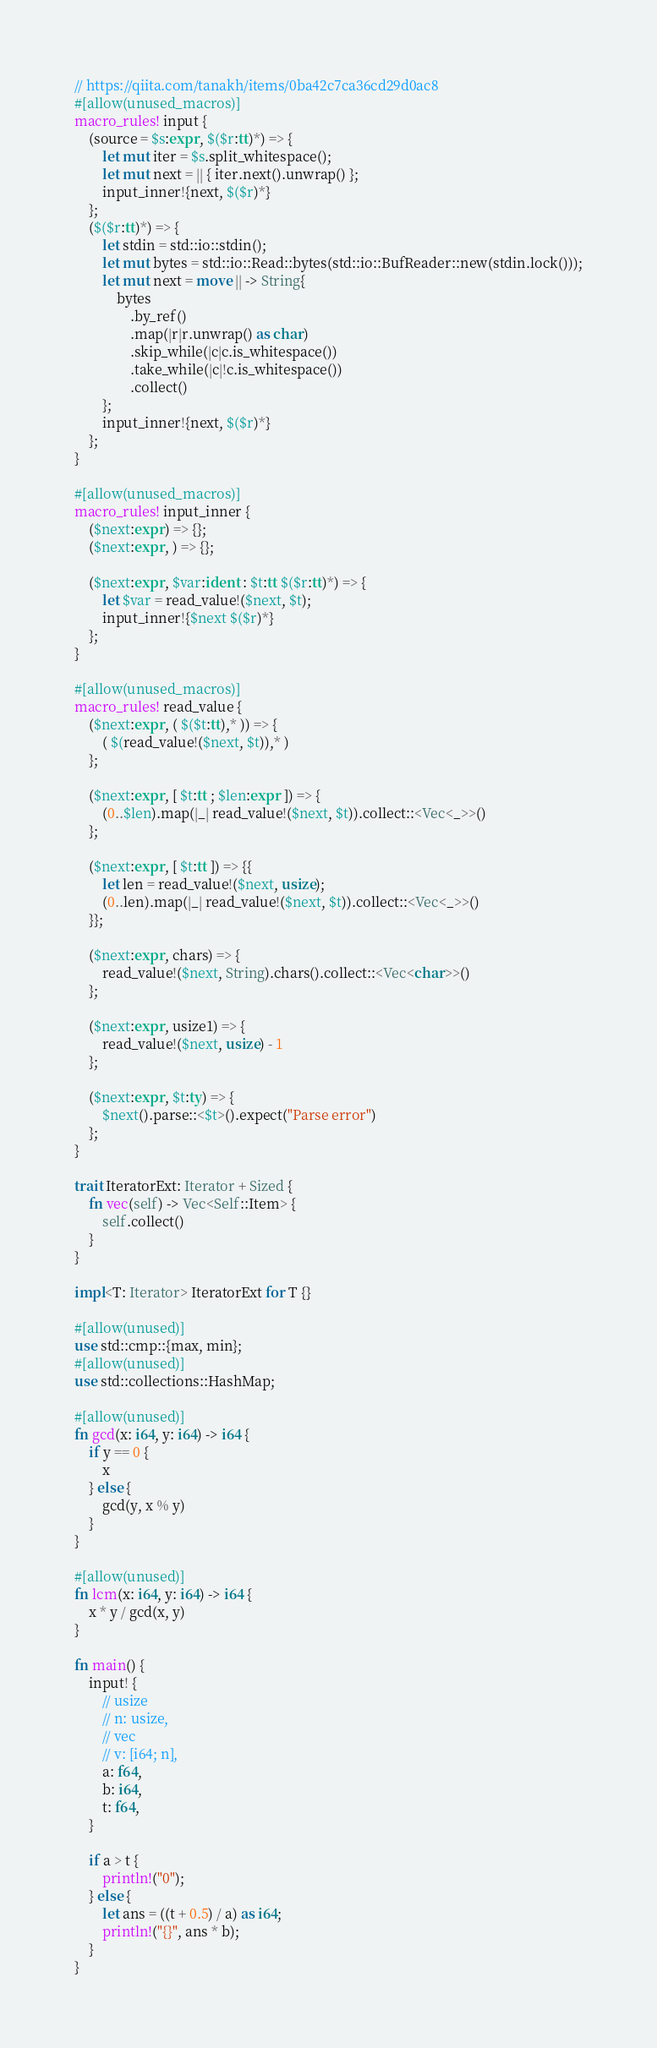Convert code to text. <code><loc_0><loc_0><loc_500><loc_500><_Rust_>// https://qiita.com/tanakh/items/0ba42c7ca36cd29d0ac8
#[allow(unused_macros)]
macro_rules! input {
    (source = $s:expr, $($r:tt)*) => {
        let mut iter = $s.split_whitespace();
        let mut next = || { iter.next().unwrap() };
        input_inner!{next, $($r)*}
    };
    ($($r:tt)*) => {
        let stdin = std::io::stdin();
        let mut bytes = std::io::Read::bytes(std::io::BufReader::new(stdin.lock()));
        let mut next = move || -> String{
            bytes
                .by_ref()
                .map(|r|r.unwrap() as char)
                .skip_while(|c|c.is_whitespace())
                .take_while(|c|!c.is_whitespace())
                .collect()
        };
        input_inner!{next, $($r)*}
    };
}

#[allow(unused_macros)]
macro_rules! input_inner {
    ($next:expr) => {};
    ($next:expr, ) => {};

    ($next:expr, $var:ident : $t:tt $($r:tt)*) => {
        let $var = read_value!($next, $t);
        input_inner!{$next $($r)*}
    };
}

#[allow(unused_macros)]
macro_rules! read_value {
    ($next:expr, ( $($t:tt),* )) => {
        ( $(read_value!($next, $t)),* )
    };

    ($next:expr, [ $t:tt ; $len:expr ]) => {
        (0..$len).map(|_| read_value!($next, $t)).collect::<Vec<_>>()
    };

    ($next:expr, [ $t:tt ]) => {{
        let len = read_value!($next, usize);
        (0..len).map(|_| read_value!($next, $t)).collect::<Vec<_>>()
    }};

    ($next:expr, chars) => {
        read_value!($next, String).chars().collect::<Vec<char>>()
    };

    ($next:expr, usize1) => {
        read_value!($next, usize) - 1
    };

    ($next:expr, $t:ty) => {
        $next().parse::<$t>().expect("Parse error")
    };
}

trait IteratorExt: Iterator + Sized {
    fn vec(self) -> Vec<Self::Item> {
        self.collect()
    }
}

impl<T: Iterator> IteratorExt for T {}

#[allow(unused)]
use std::cmp::{max, min};
#[allow(unused)]
use std::collections::HashMap;

#[allow(unused)]
fn gcd(x: i64, y: i64) -> i64 {
    if y == 0 {
        x
    } else {
        gcd(y, x % y)
    }
}

#[allow(unused)]
fn lcm(x: i64, y: i64) -> i64 {
    x * y / gcd(x, y)
}

fn main() {
    input! {
        // usize
        // n: usize,
        // vec
        // v: [i64; n],
        a: f64,
        b: i64,
        t: f64,
    }

    if a > t {
        println!("0");
    } else {
        let ans = ((t + 0.5) / a) as i64;
        println!("{}", ans * b);
    }
}
</code> 